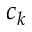<formula> <loc_0><loc_0><loc_500><loc_500>c _ { k }</formula> 